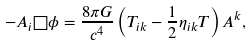Convert formula to latex. <formula><loc_0><loc_0><loc_500><loc_500>- A _ { i } \square \phi = \frac { 8 \pi G } { c ^ { 4 } } \left ( T _ { i k } - \frac { 1 } { 2 } \eta _ { i k } T \right ) A ^ { k } ,</formula> 